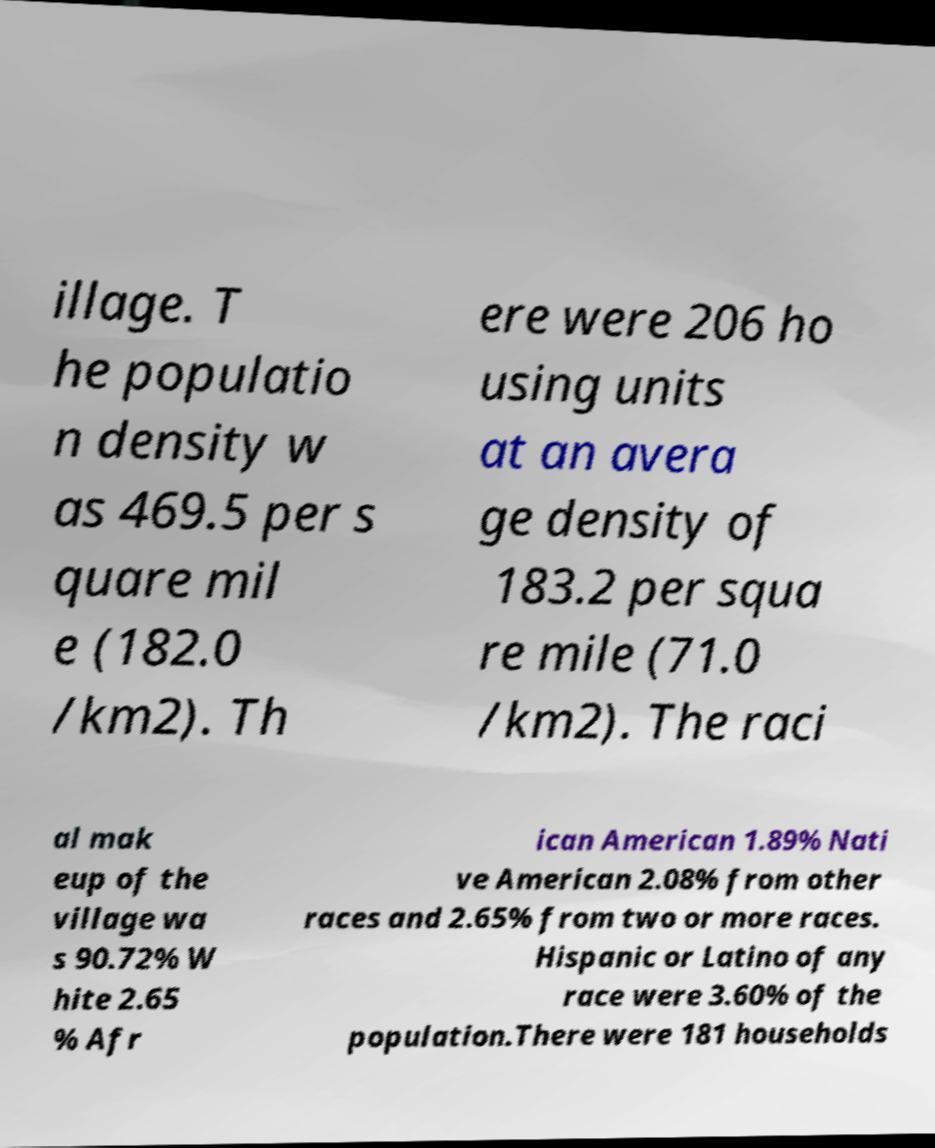Can you read and provide the text displayed in the image?This photo seems to have some interesting text. Can you extract and type it out for me? illage. T he populatio n density w as 469.5 per s quare mil e (182.0 /km2). Th ere were 206 ho using units at an avera ge density of 183.2 per squa re mile (71.0 /km2). The raci al mak eup of the village wa s 90.72% W hite 2.65 % Afr ican American 1.89% Nati ve American 2.08% from other races and 2.65% from two or more races. Hispanic or Latino of any race were 3.60% of the population.There were 181 households 